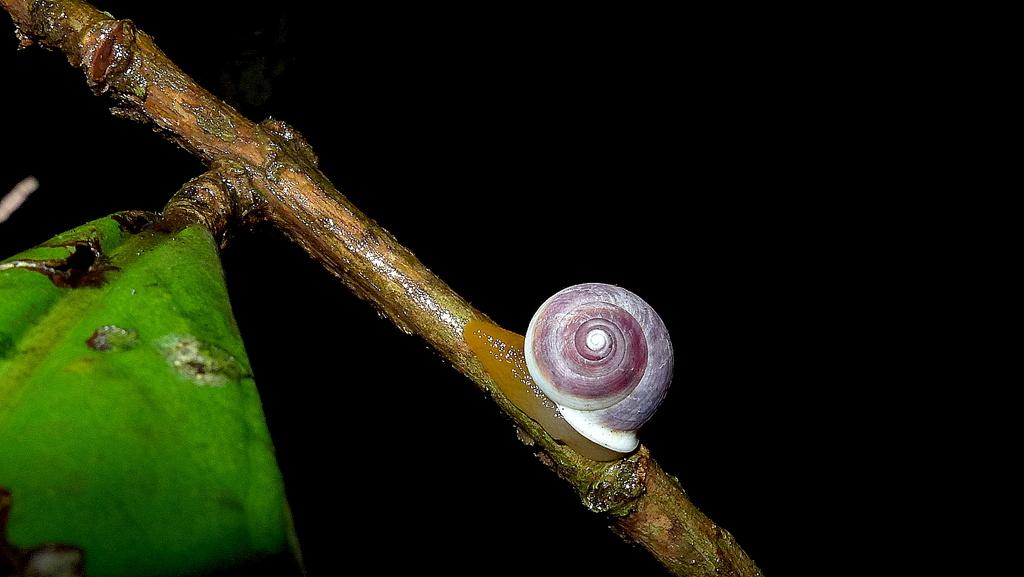What is the main subject of the image? The main subject of the image is a snail on the branch of a tree. What else can be seen on the left side of the image? There is a leaf on the left side of the image. How would you describe the overall appearance of the image? The background of the image is dark. What type of ring can be seen on the snail's stomach in the image? There is no ring present on the snail's stomach in the image, as the snail is not wearing any jewelry. 